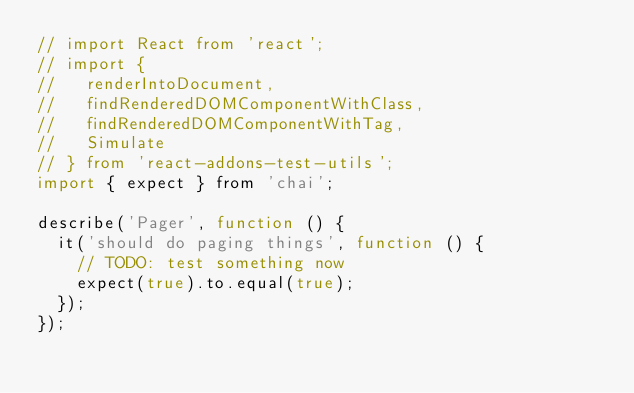Convert code to text. <code><loc_0><loc_0><loc_500><loc_500><_JavaScript_>// import React from 'react';
// import {
//   renderIntoDocument,
//   findRenderedDOMComponentWithClass,
//   findRenderedDOMComponentWithTag,
//   Simulate
// } from 'react-addons-test-utils';
import { expect } from 'chai';

describe('Pager', function () {
  it('should do paging things', function () {
    // TODO: test something now
    expect(true).to.equal(true);
  });
});
</code> 